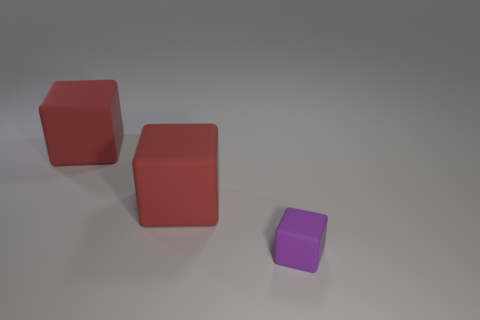Can you describe the size and colors of the blocks? Certainly! There are three blocks in the image: two larger blocks are red and identical in size, while the smaller block is purple. They present a simple yet interesting study in geometry and color contrast. 